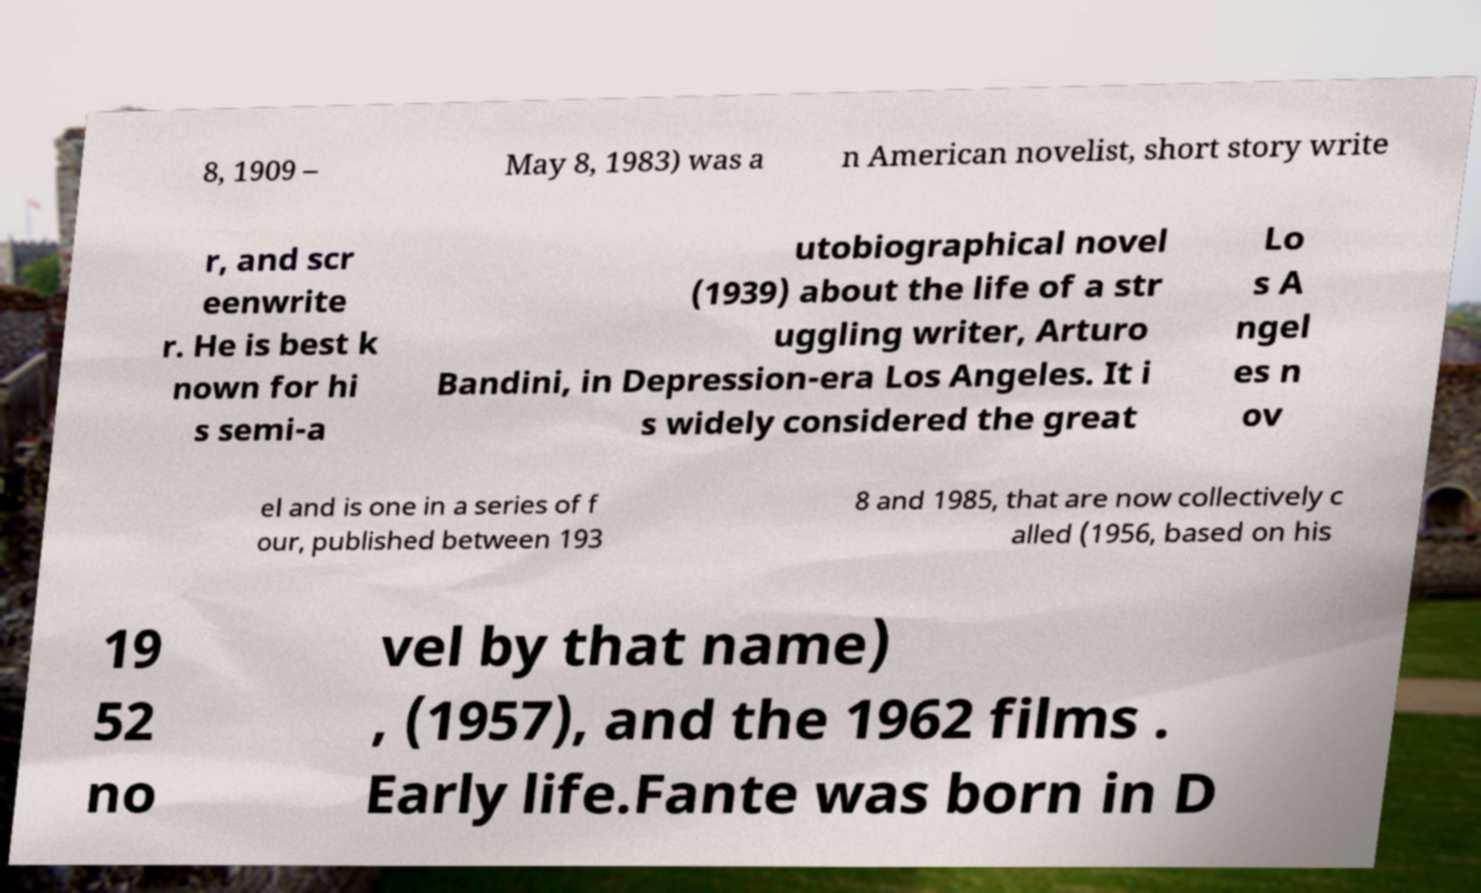Could you extract and type out the text from this image? 8, 1909 – May 8, 1983) was a n American novelist, short story write r, and scr eenwrite r. He is best k nown for hi s semi-a utobiographical novel (1939) about the life of a str uggling writer, Arturo Bandini, in Depression-era Los Angeles. It i s widely considered the great Lo s A ngel es n ov el and is one in a series of f our, published between 193 8 and 1985, that are now collectively c alled (1956, based on his 19 52 no vel by that name) , (1957), and the 1962 films . Early life.Fante was born in D 